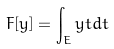<formula> <loc_0><loc_0><loc_500><loc_500>F [ y ] = \int _ { E } y t d t</formula> 